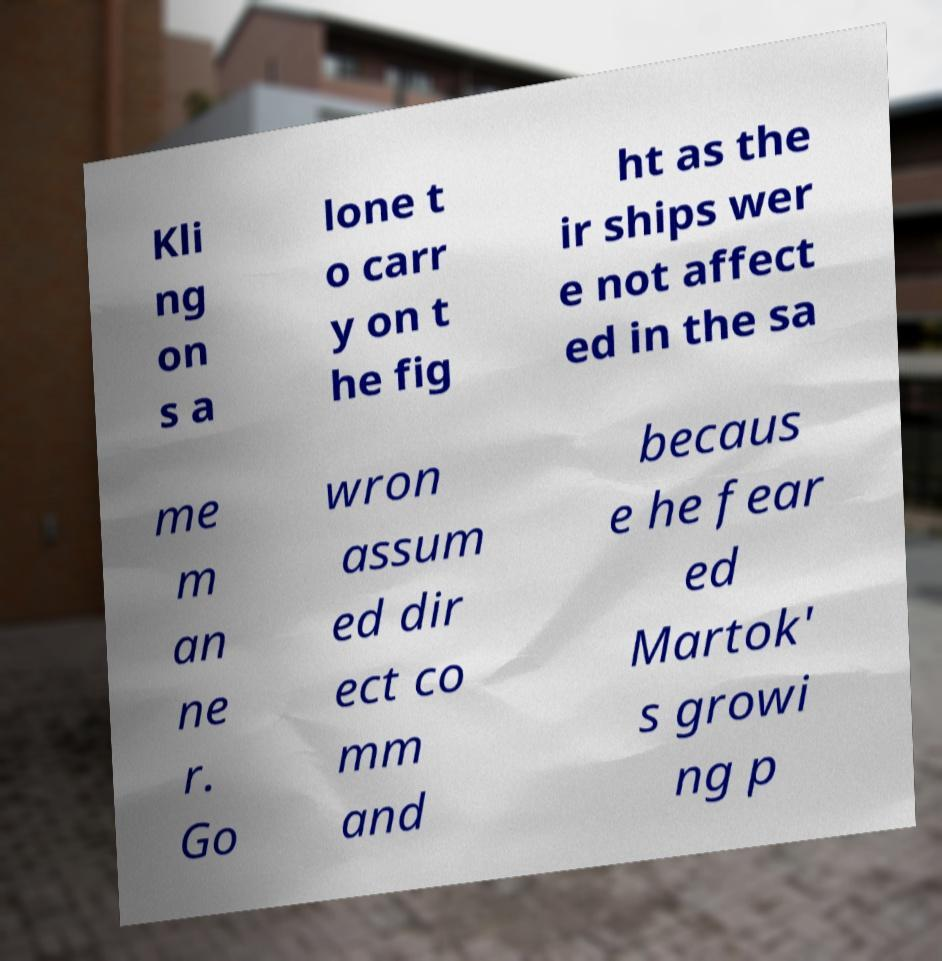Please read and relay the text visible in this image. What does it say? Kli ng on s a lone t o carr y on t he fig ht as the ir ships wer e not affect ed in the sa me m an ne r. Go wron assum ed dir ect co mm and becaus e he fear ed Martok' s growi ng p 